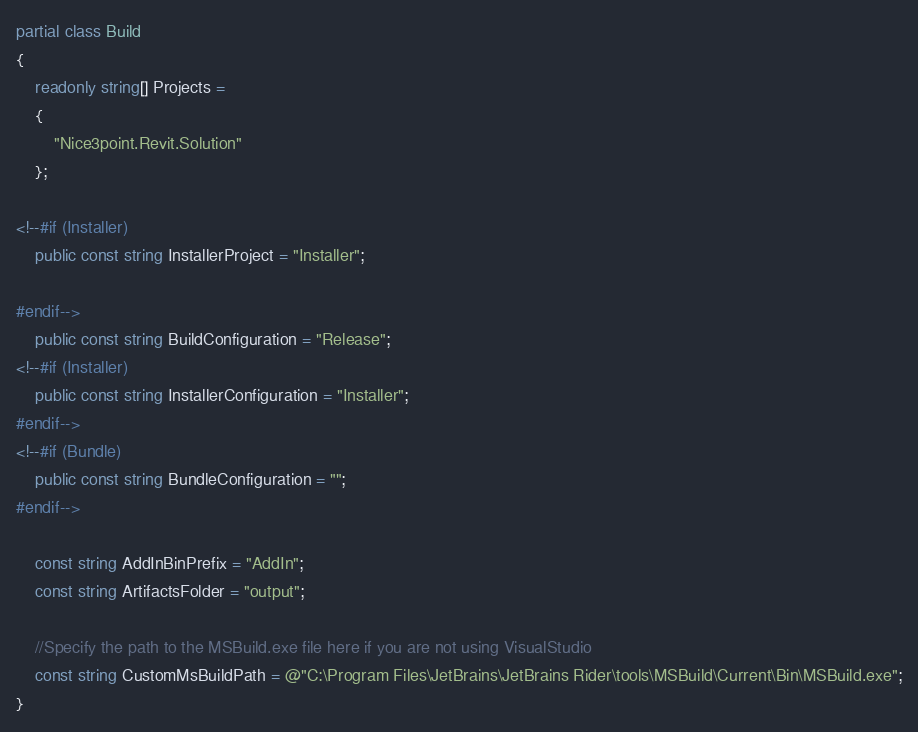Convert code to text. <code><loc_0><loc_0><loc_500><loc_500><_C#_>partial class Build
{
    readonly string[] Projects =
    {
        "Nice3point.Revit.Solution"
    };

<!--#if (Installer)
    public const string InstallerProject = "Installer";

#endif-->
    public const string BuildConfiguration = "Release";
<!--#if (Installer)
    public const string InstallerConfiguration = "Installer";
#endif-->
<!--#if (Bundle)
    public const string BundleConfiguration = "";
#endif-->

    const string AddInBinPrefix = "AddIn";
    const string ArtifactsFolder = "output";

    //Specify the path to the MSBuild.exe file here if you are not using VisualStudio
    const string CustomMsBuildPath = @"C:\Program Files\JetBrains\JetBrains Rider\tools\MSBuild\Current\Bin\MSBuild.exe";
}</code> 